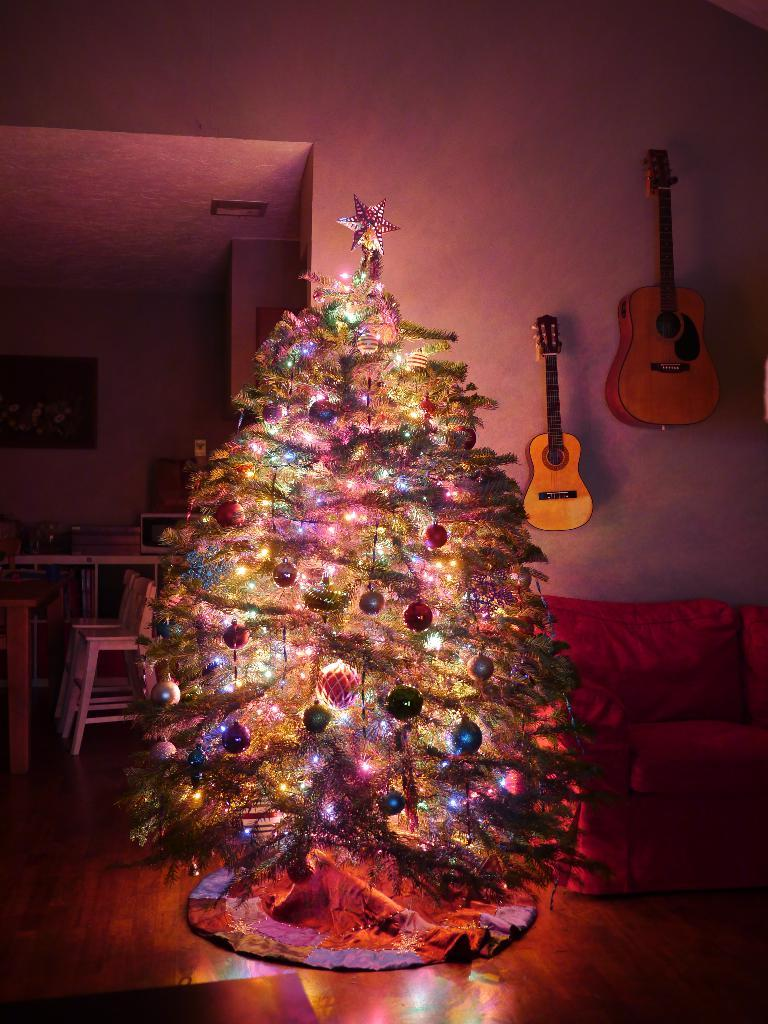What type of tree is in the image? There is a Christmas tree in the image. What type of furniture is in the image? There is a couch in the image. What can be seen in the background of the image? There is a wall and guitars in the background of the image. What type of driving is taking place in the image? There is no driving present in the image; it features a Christmas tree, a couch, and guitars in the background. 